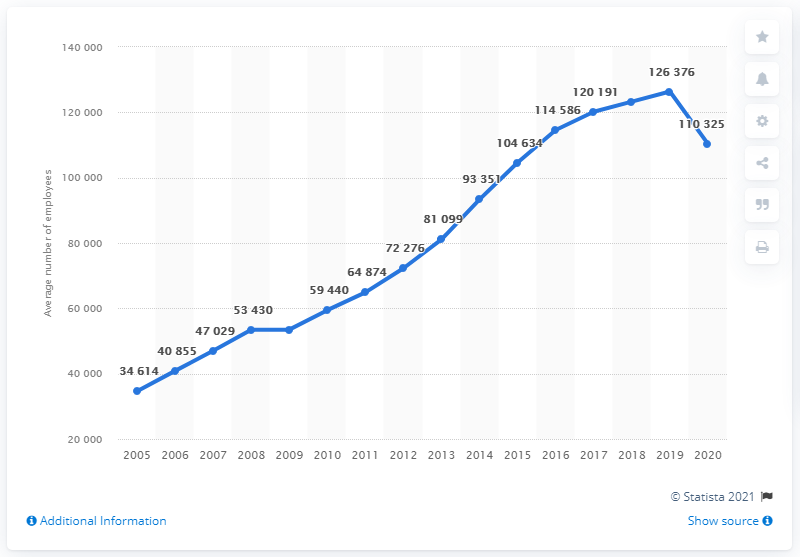Identify some key points in this picture. The difference between the maximum and minimum average number of employees working in H&M in a year is 91,762 employees. In 2005, the average number of employees working at H&M was at its minimum. 